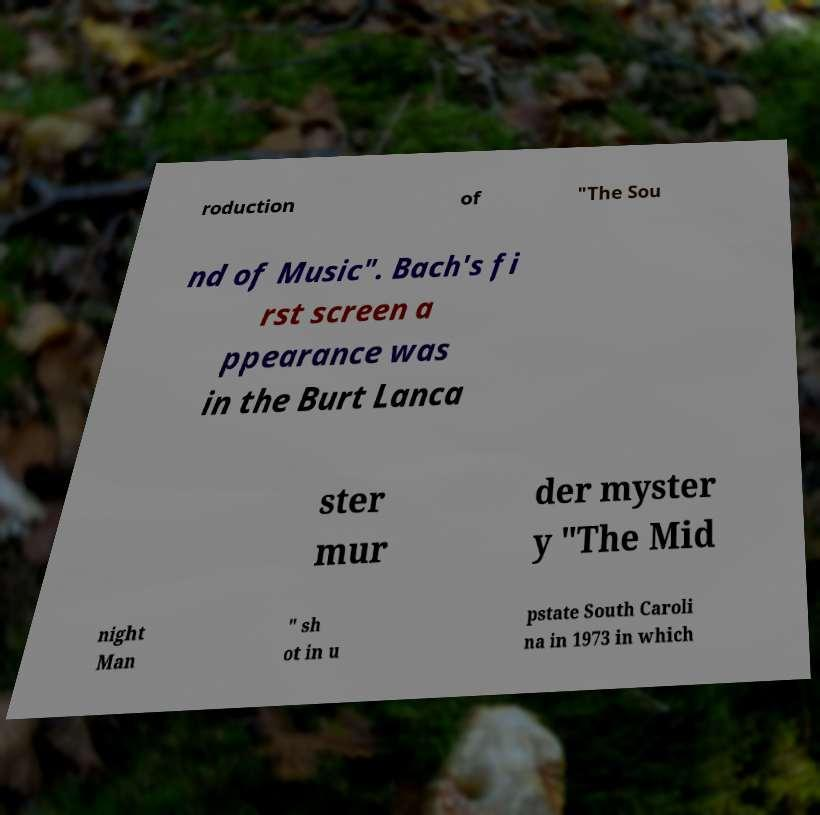There's text embedded in this image that I need extracted. Can you transcribe it verbatim? roduction of "The Sou nd of Music". Bach's fi rst screen a ppearance was in the Burt Lanca ster mur der myster y "The Mid night Man " sh ot in u pstate South Caroli na in 1973 in which 